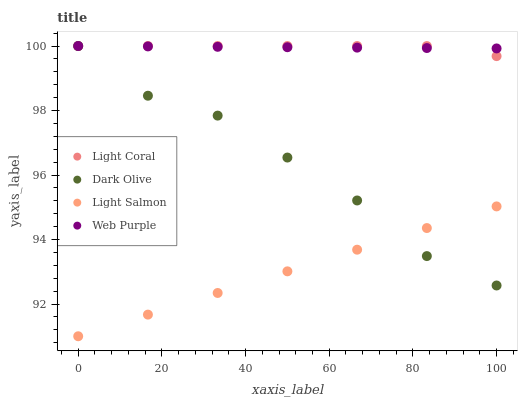Does Light Salmon have the minimum area under the curve?
Answer yes or no. Yes. Does Light Coral have the maximum area under the curve?
Answer yes or no. Yes. Does Dark Olive have the minimum area under the curve?
Answer yes or no. No. Does Dark Olive have the maximum area under the curve?
Answer yes or no. No. Is Light Salmon the smoothest?
Answer yes or no. Yes. Is Dark Olive the roughest?
Answer yes or no. Yes. Is Dark Olive the smoothest?
Answer yes or no. No. Is Light Salmon the roughest?
Answer yes or no. No. Does Light Salmon have the lowest value?
Answer yes or no. Yes. Does Dark Olive have the lowest value?
Answer yes or no. No. Does Web Purple have the highest value?
Answer yes or no. Yes. Does Light Salmon have the highest value?
Answer yes or no. No. Is Light Salmon less than Web Purple?
Answer yes or no. Yes. Is Web Purple greater than Light Salmon?
Answer yes or no. Yes. Does Light Coral intersect Dark Olive?
Answer yes or no. Yes. Is Light Coral less than Dark Olive?
Answer yes or no. No. Is Light Coral greater than Dark Olive?
Answer yes or no. No. Does Light Salmon intersect Web Purple?
Answer yes or no. No. 